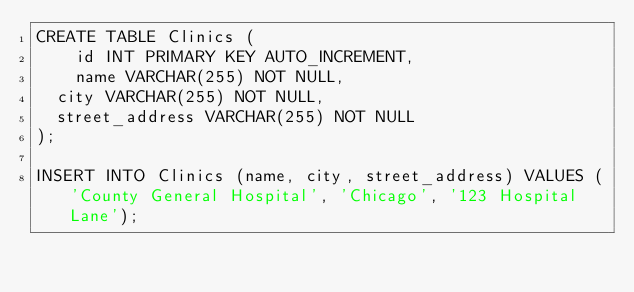Convert code to text. <code><loc_0><loc_0><loc_500><loc_500><_SQL_>CREATE TABLE Clinics (
    id INT PRIMARY KEY AUTO_INCREMENT,
    name VARCHAR(255) NOT NULL,
	city VARCHAR(255) NOT NULL,
	street_address VARCHAR(255) NOT NULL
);

INSERT INTO Clinics (name, city, street_address) VALUES ('County General Hospital', 'Chicago', '123 Hospital Lane');</code> 